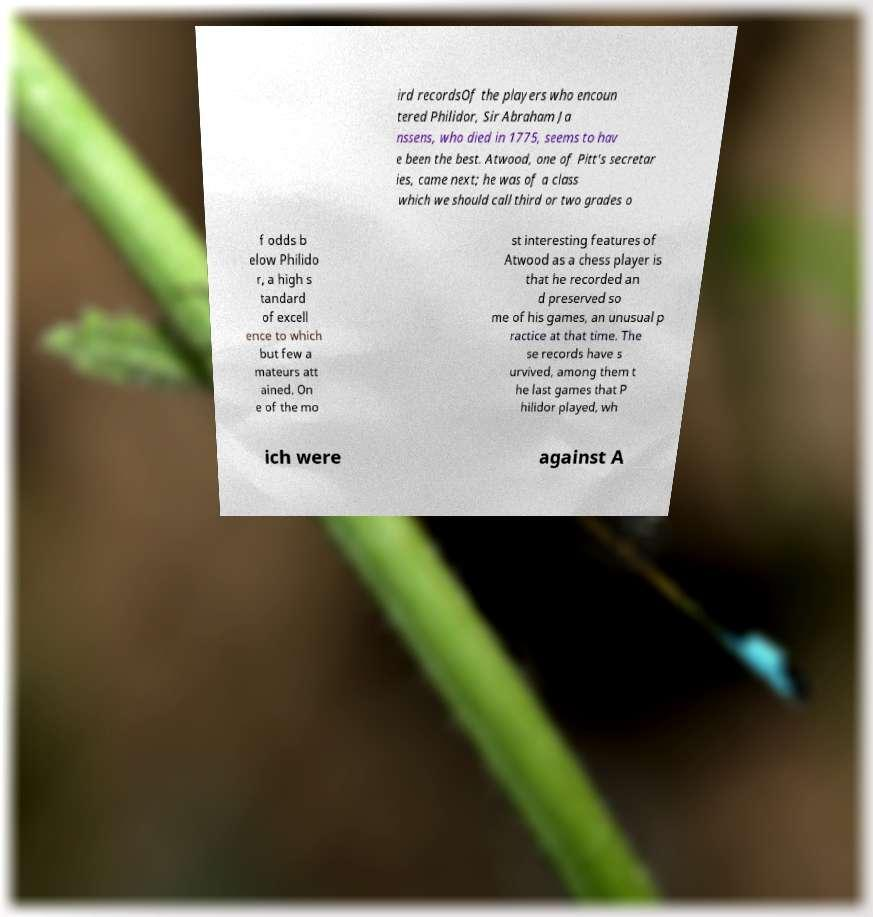Can you read and provide the text displayed in the image?This photo seems to have some interesting text. Can you extract and type it out for me? ird recordsOf the players who encoun tered Philidor, Sir Abraham Ja nssens, who died in 1775, seems to hav e been the best. Atwood, one of Pitt's secretar ies, came next; he was of a class which we should call third or two grades o f odds b elow Philido r, a high s tandard of excell ence to which but few a mateurs att ained. On e of the mo st interesting features of Atwood as a chess player is that he recorded an d preserved so me of his games, an unusual p ractice at that time. The se records have s urvived, among them t he last games that P hilidor played, wh ich were against A 